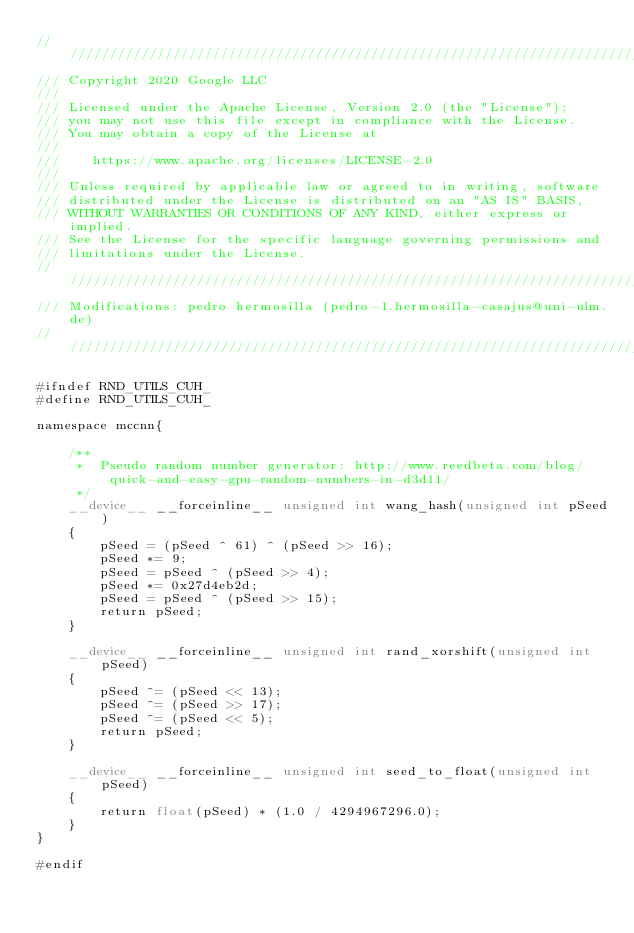Convert code to text. <code><loc_0><loc_0><loc_500><loc_500><_Cuda_>/////////////////////////////////////////////////////////////////////////////
/// Copyright 2020 Google LLC
///
/// Licensed under the Apache License, Version 2.0 (the "License");
/// you may not use this file except in compliance with the License.
/// You may obtain a copy of the License at
///
///    https://www.apache.org/licenses/LICENSE-2.0
///
/// Unless required by applicable law or agreed to in writing, software
/// distributed under the License is distributed on an "AS IS" BASIS,
/// WITHOUT WARRANTIES OR CONDITIONS OF ANY KIND, either express or implied.
/// See the License for the specific language governing permissions and
/// limitations under the License.
/////////////////////////////////////////////////////////////////////////////
/// Modifications: pedro hermosilla (pedro-1.hermosilla-casajus@uni-ulm.de)
/////////////////////////////////////////////////////////////////////////////

#ifndef RND_UTILS_CUH_
#define RND_UTILS_CUH_

namespace mccnn{

    /**
     *  Pseudo random number generator: http://www.reedbeta.com/blog/quick-and-easy-gpu-random-numbers-in-d3d11/
     */
    __device__ __forceinline__ unsigned int wang_hash(unsigned int pSeed)
    {
        pSeed = (pSeed ^ 61) ^ (pSeed >> 16);
        pSeed *= 9;
        pSeed = pSeed ^ (pSeed >> 4);
        pSeed *= 0x27d4eb2d;
        pSeed = pSeed ^ (pSeed >> 15);
        return pSeed;
    }

    __device__ __forceinline__ unsigned int rand_xorshift(unsigned int pSeed)
    {
        pSeed ^= (pSeed << 13);
        pSeed ^= (pSeed >> 17);
        pSeed ^= (pSeed << 5);
        return pSeed;
    }

    __device__ __forceinline__ unsigned int seed_to_float(unsigned int pSeed)
    {
        return float(pSeed) * (1.0 / 4294967296.0);
    }
}

#endif</code> 